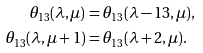Convert formula to latex. <formula><loc_0><loc_0><loc_500><loc_500>\theta _ { 1 3 } ( \lambda , \mu ) & = \theta _ { 1 3 } ( \lambda - 1 3 , \mu ) , \\ \theta _ { 1 3 } ( \lambda , \mu + 1 ) & = \theta _ { 1 3 } ( \lambda + 2 , \mu ) .</formula> 